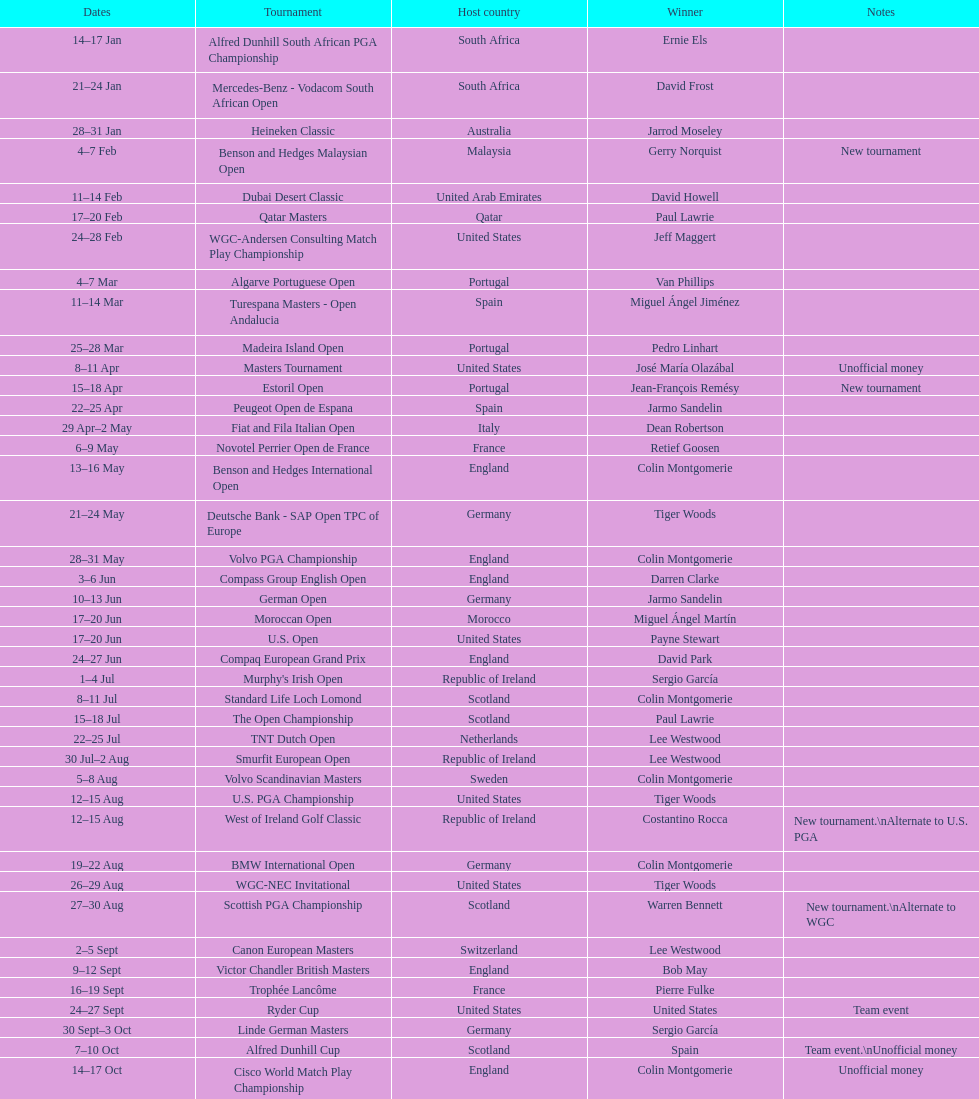Besides the qatar masters, can you mention a competition that took place in february? Dubai Desert Classic. 